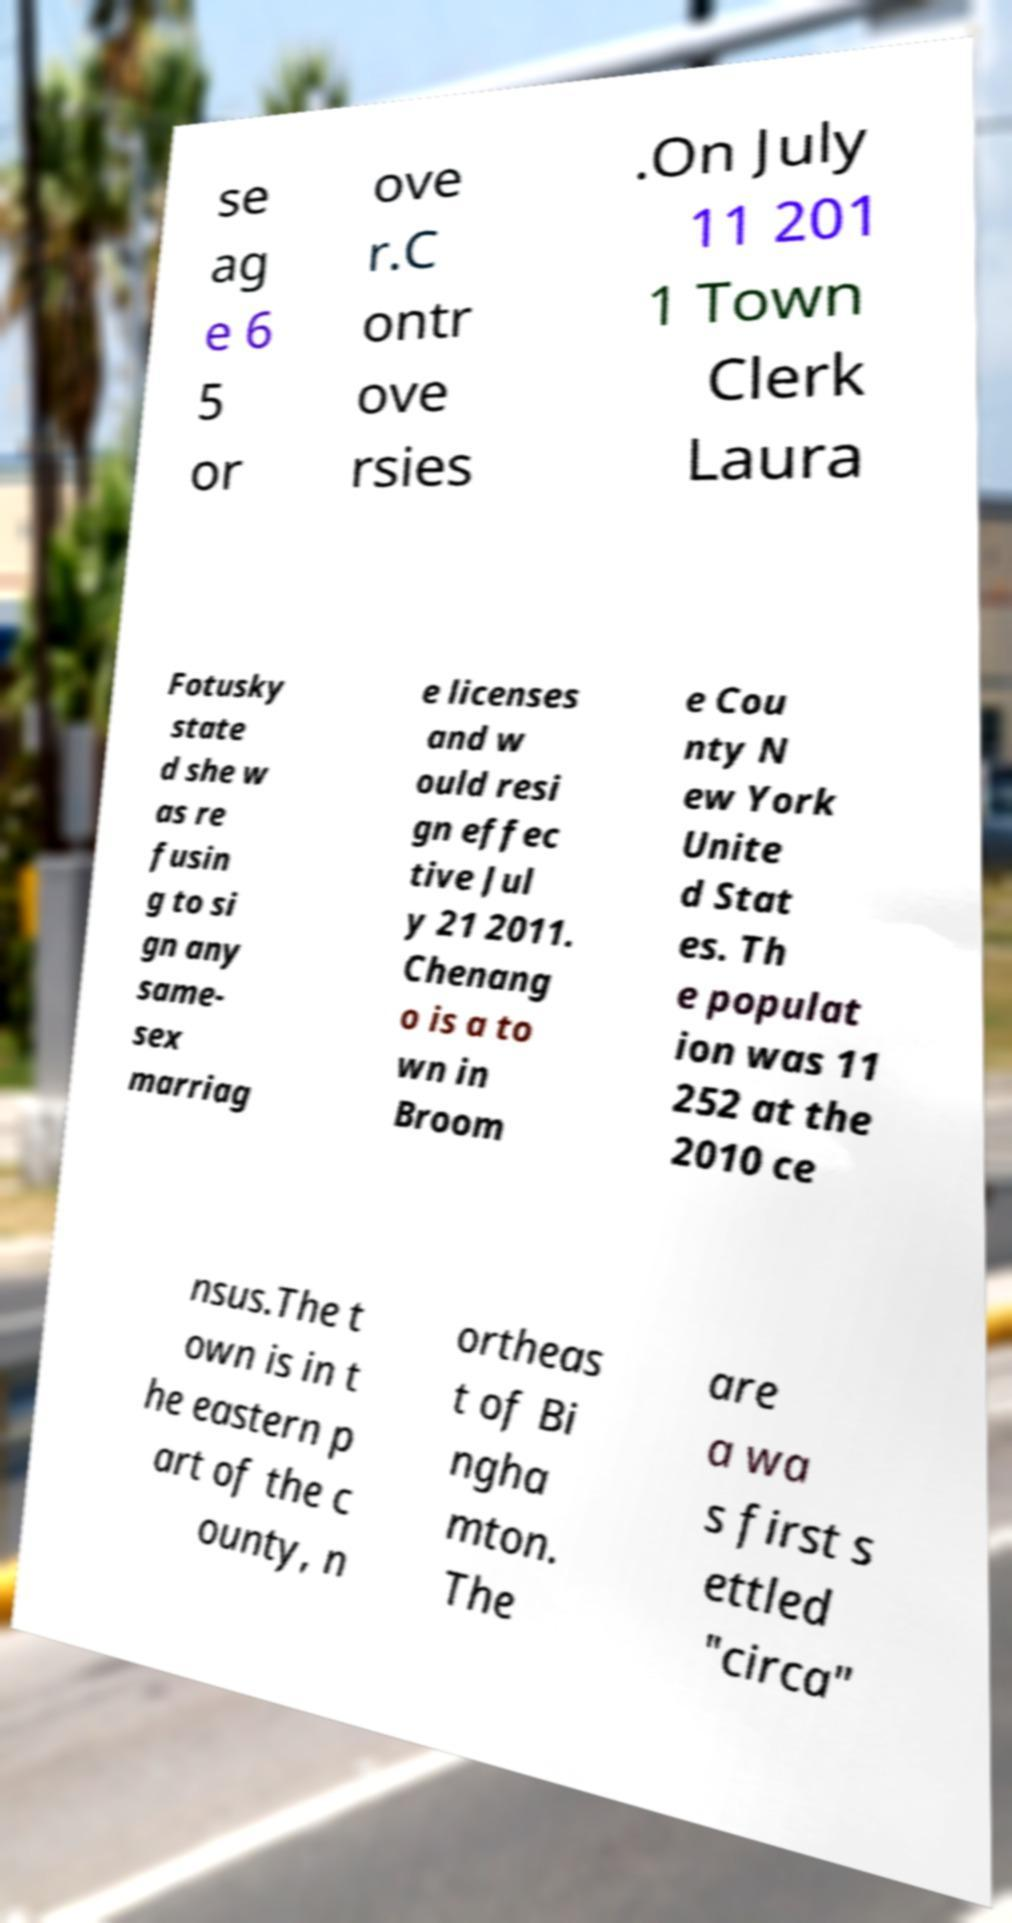I need the written content from this picture converted into text. Can you do that? se ag e 6 5 or ove r.C ontr ove rsies .On July 11 201 1 Town Clerk Laura Fotusky state d she w as re fusin g to si gn any same- sex marriag e licenses and w ould resi gn effec tive Jul y 21 2011. Chenang o is a to wn in Broom e Cou nty N ew York Unite d Stat es. Th e populat ion was 11 252 at the 2010 ce nsus.The t own is in t he eastern p art of the c ounty, n ortheas t of Bi ngha mton. The are a wa s first s ettled "circa" 